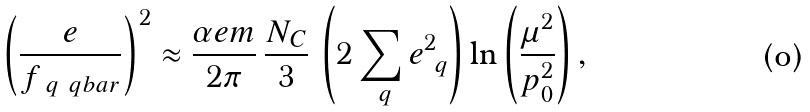<formula> <loc_0><loc_0><loc_500><loc_500>\left ( \frac { e } { f _ { \ q \ q b a r } } \right ) ^ { 2 } \approx \frac { \alpha e m } { 2 \pi } \, \frac { N _ { C } } { 3 } \, \left ( 2 \sum _ { \ q } e _ { \ q } ^ { 2 } \right ) \ln \left ( \frac { \mu ^ { 2 } } { p _ { 0 } ^ { 2 } } \right ) ,</formula> 